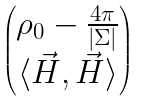<formula> <loc_0><loc_0><loc_500><loc_500>\begin{pmatrix} \rho _ { 0 } - \frac { 4 \pi } { | \Sigma | } \\ \langle \vec { H } , \vec { H } \rangle \end{pmatrix}</formula> 